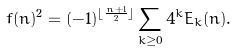Convert formula to latex. <formula><loc_0><loc_0><loc_500><loc_500>f ( n ) ^ { 2 } = ( - 1 ) ^ { \lfloor \frac { n + 1 } { 2 } \rfloor } \sum _ { k \geq 0 } 4 ^ { k } E _ { k } ( n ) .</formula> 